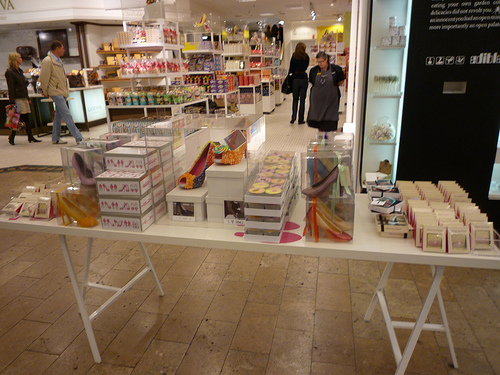<image>
Is there a table under the products? Yes. The table is positioned underneath the products, with the products above it in the vertical space. Where is the woman in relation to the table? Is it behind the table? Yes. From this viewpoint, the woman is positioned behind the table, with the table partially or fully occluding the woman. Is there a box behind the bags? No. The box is not behind the bags. From this viewpoint, the box appears to be positioned elsewhere in the scene. 